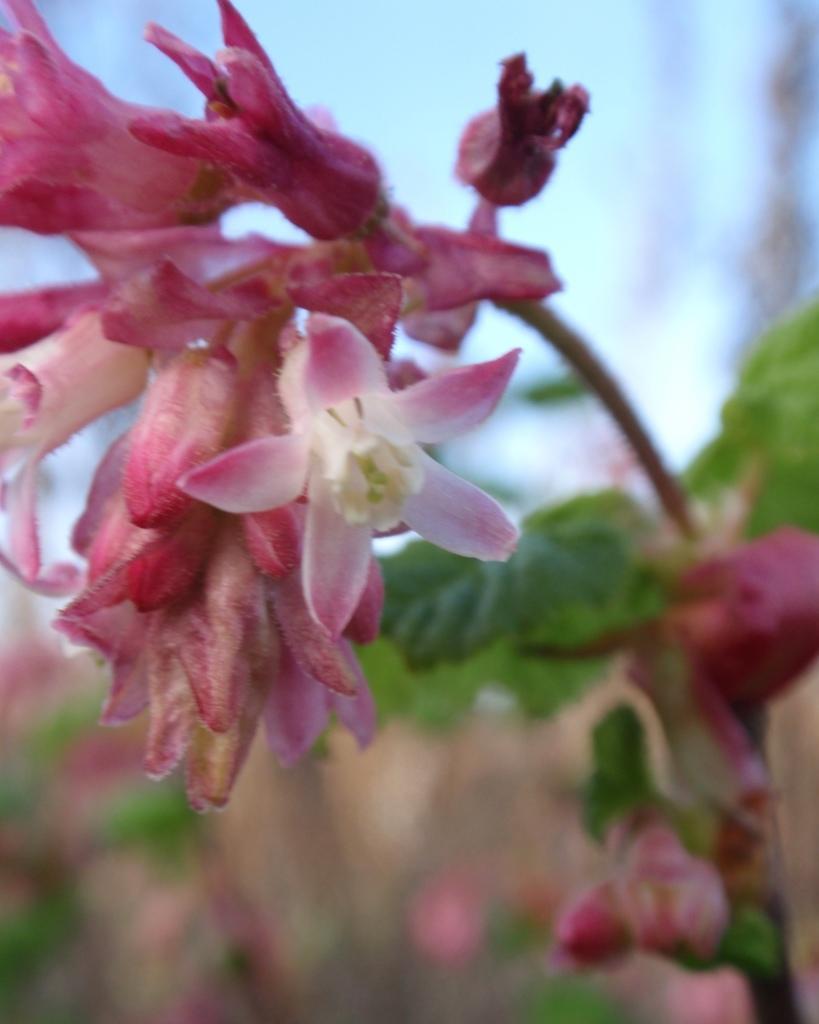In one or two sentences, can you explain what this image depicts? In the foreground of the picture there are flowers, buds, leaves, stem, it is a plant. The background is blurred. 